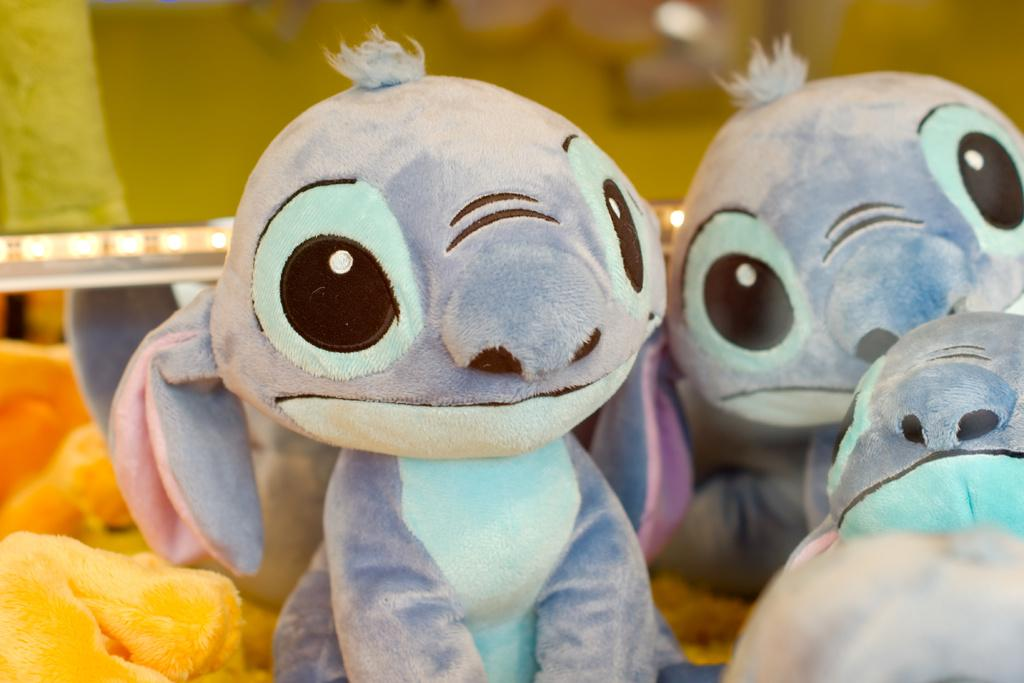What is the main subject of the image? The main subject of the image is many toys. What can be seen in the background of the image? There are lights and a wall in the background of the image. What type of sound system is visible in the image? There is no sound system present in the image. What need does the image address? The image does not address any specific need; it simply shows toys and a background. 